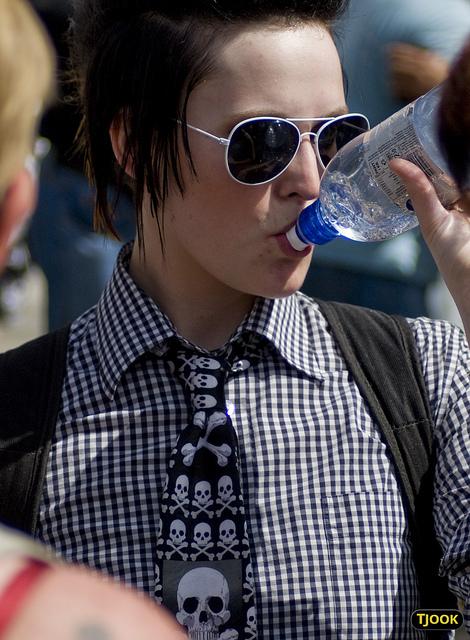What is the man doing?
Answer briefly. Drinking water. Is this person at work?
Give a very brief answer. No. Is the boy thirsty?
Answer briefly. Yes. IS this man young or old?
Answer briefly. Young. What is all over his necktie?
Quick response, please. Skulls. 